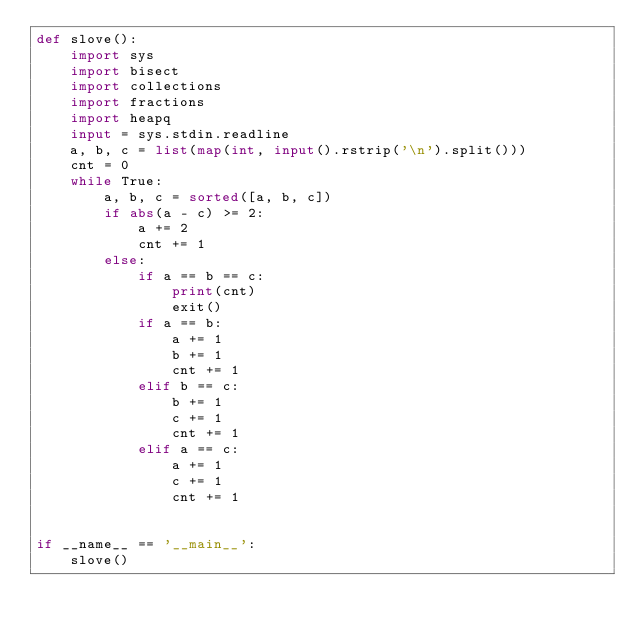Convert code to text. <code><loc_0><loc_0><loc_500><loc_500><_Python_>def slove():
    import sys
    import bisect
    import collections
    import fractions
    import heapq
    input = sys.stdin.readline
    a, b, c = list(map(int, input().rstrip('\n').split()))
    cnt = 0
    while True:
        a, b, c = sorted([a, b, c])
        if abs(a - c) >= 2:
            a += 2
            cnt += 1
        else:
            if a == b == c:
                print(cnt)
                exit()
            if a == b:
                a += 1
                b += 1
                cnt += 1
            elif b == c:
                b += 1
                c += 1
                cnt += 1
            elif a == c:
                a += 1
                c += 1
                cnt += 1


if __name__ == '__main__':
    slove()
</code> 